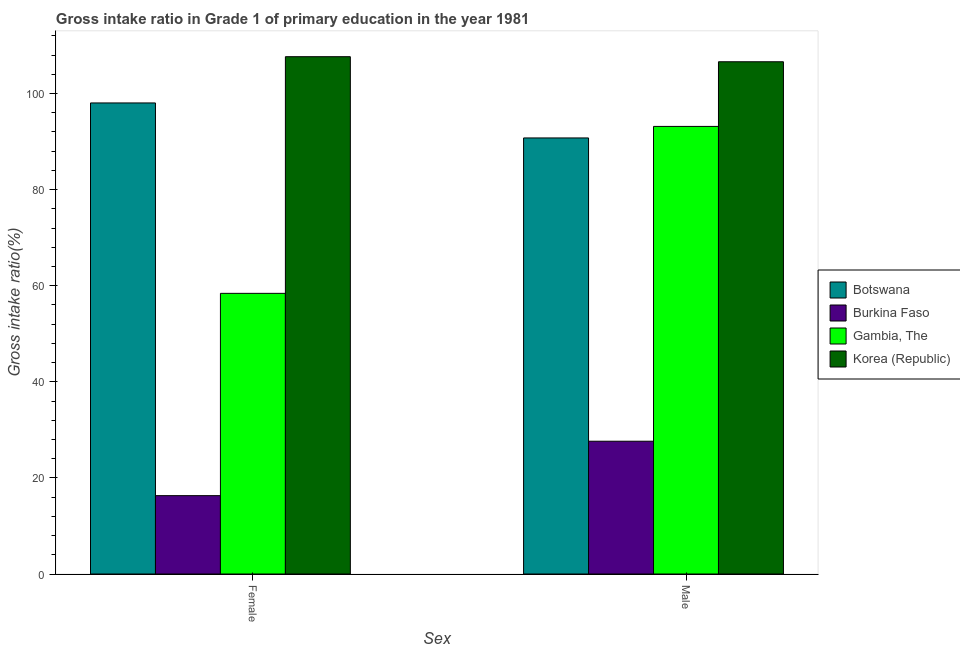How many groups of bars are there?
Make the answer very short. 2. Are the number of bars per tick equal to the number of legend labels?
Provide a succinct answer. Yes. What is the gross intake ratio(female) in Botswana?
Your answer should be very brief. 98.05. Across all countries, what is the maximum gross intake ratio(male)?
Provide a short and direct response. 106.62. Across all countries, what is the minimum gross intake ratio(female)?
Make the answer very short. 16.31. In which country was the gross intake ratio(male) minimum?
Your answer should be very brief. Burkina Faso. What is the total gross intake ratio(male) in the graph?
Keep it short and to the point. 318.18. What is the difference between the gross intake ratio(female) in Korea (Republic) and that in Gambia, The?
Give a very brief answer. 49.26. What is the difference between the gross intake ratio(female) in Burkina Faso and the gross intake ratio(male) in Gambia, The?
Offer a terse response. -76.85. What is the average gross intake ratio(female) per country?
Provide a short and direct response. 70.11. What is the difference between the gross intake ratio(female) and gross intake ratio(male) in Botswana?
Give a very brief answer. 7.28. What is the ratio of the gross intake ratio(female) in Burkina Faso to that in Gambia, The?
Give a very brief answer. 0.28. In how many countries, is the gross intake ratio(female) greater than the average gross intake ratio(female) taken over all countries?
Make the answer very short. 2. What does the 3rd bar from the left in Male represents?
Your answer should be very brief. Gambia, The. What does the 3rd bar from the right in Male represents?
Offer a very short reply. Burkina Faso. How many bars are there?
Keep it short and to the point. 8. How many countries are there in the graph?
Your response must be concise. 4. Are the values on the major ticks of Y-axis written in scientific E-notation?
Give a very brief answer. No. Where does the legend appear in the graph?
Offer a very short reply. Center right. How many legend labels are there?
Offer a very short reply. 4. How are the legend labels stacked?
Offer a terse response. Vertical. What is the title of the graph?
Provide a short and direct response. Gross intake ratio in Grade 1 of primary education in the year 1981. Does "Monaco" appear as one of the legend labels in the graph?
Make the answer very short. No. What is the label or title of the X-axis?
Your answer should be very brief. Sex. What is the label or title of the Y-axis?
Your response must be concise. Gross intake ratio(%). What is the Gross intake ratio(%) in Botswana in Female?
Provide a short and direct response. 98.05. What is the Gross intake ratio(%) of Burkina Faso in Female?
Provide a succinct answer. 16.31. What is the Gross intake ratio(%) of Gambia, The in Female?
Give a very brief answer. 58.41. What is the Gross intake ratio(%) in Korea (Republic) in Female?
Keep it short and to the point. 107.67. What is the Gross intake ratio(%) of Botswana in Male?
Offer a very short reply. 90.76. What is the Gross intake ratio(%) of Burkina Faso in Male?
Keep it short and to the point. 27.64. What is the Gross intake ratio(%) in Gambia, The in Male?
Offer a very short reply. 93.16. What is the Gross intake ratio(%) in Korea (Republic) in Male?
Offer a very short reply. 106.62. Across all Sex, what is the maximum Gross intake ratio(%) in Botswana?
Offer a very short reply. 98.05. Across all Sex, what is the maximum Gross intake ratio(%) of Burkina Faso?
Ensure brevity in your answer.  27.64. Across all Sex, what is the maximum Gross intake ratio(%) of Gambia, The?
Keep it short and to the point. 93.16. Across all Sex, what is the maximum Gross intake ratio(%) in Korea (Republic)?
Offer a terse response. 107.67. Across all Sex, what is the minimum Gross intake ratio(%) in Botswana?
Your response must be concise. 90.76. Across all Sex, what is the minimum Gross intake ratio(%) of Burkina Faso?
Give a very brief answer. 16.31. Across all Sex, what is the minimum Gross intake ratio(%) of Gambia, The?
Give a very brief answer. 58.41. Across all Sex, what is the minimum Gross intake ratio(%) of Korea (Republic)?
Make the answer very short. 106.62. What is the total Gross intake ratio(%) in Botswana in the graph?
Keep it short and to the point. 188.81. What is the total Gross intake ratio(%) in Burkina Faso in the graph?
Your answer should be very brief. 43.95. What is the total Gross intake ratio(%) of Gambia, The in the graph?
Offer a terse response. 151.58. What is the total Gross intake ratio(%) of Korea (Republic) in the graph?
Offer a terse response. 214.29. What is the difference between the Gross intake ratio(%) in Botswana in Female and that in Male?
Ensure brevity in your answer.  7.28. What is the difference between the Gross intake ratio(%) of Burkina Faso in Female and that in Male?
Your answer should be very brief. -11.33. What is the difference between the Gross intake ratio(%) in Gambia, The in Female and that in Male?
Provide a short and direct response. -34.75. What is the difference between the Gross intake ratio(%) in Korea (Republic) in Female and that in Male?
Keep it short and to the point. 1.05. What is the difference between the Gross intake ratio(%) in Botswana in Female and the Gross intake ratio(%) in Burkina Faso in Male?
Your answer should be very brief. 70.41. What is the difference between the Gross intake ratio(%) of Botswana in Female and the Gross intake ratio(%) of Gambia, The in Male?
Your answer should be compact. 4.89. What is the difference between the Gross intake ratio(%) in Botswana in Female and the Gross intake ratio(%) in Korea (Republic) in Male?
Your response must be concise. -8.57. What is the difference between the Gross intake ratio(%) in Burkina Faso in Female and the Gross intake ratio(%) in Gambia, The in Male?
Your answer should be very brief. -76.85. What is the difference between the Gross intake ratio(%) in Burkina Faso in Female and the Gross intake ratio(%) in Korea (Republic) in Male?
Provide a succinct answer. -90.31. What is the difference between the Gross intake ratio(%) of Gambia, The in Female and the Gross intake ratio(%) of Korea (Republic) in Male?
Your answer should be compact. -48.2. What is the average Gross intake ratio(%) in Botswana per Sex?
Give a very brief answer. 94.41. What is the average Gross intake ratio(%) of Burkina Faso per Sex?
Provide a succinct answer. 21.97. What is the average Gross intake ratio(%) in Gambia, The per Sex?
Offer a terse response. 75.79. What is the average Gross intake ratio(%) of Korea (Republic) per Sex?
Your answer should be compact. 107.15. What is the difference between the Gross intake ratio(%) in Botswana and Gross intake ratio(%) in Burkina Faso in Female?
Ensure brevity in your answer.  81.74. What is the difference between the Gross intake ratio(%) in Botswana and Gross intake ratio(%) in Gambia, The in Female?
Keep it short and to the point. 39.63. What is the difference between the Gross intake ratio(%) of Botswana and Gross intake ratio(%) of Korea (Republic) in Female?
Keep it short and to the point. -9.63. What is the difference between the Gross intake ratio(%) of Burkina Faso and Gross intake ratio(%) of Gambia, The in Female?
Provide a succinct answer. -42.11. What is the difference between the Gross intake ratio(%) of Burkina Faso and Gross intake ratio(%) of Korea (Republic) in Female?
Offer a very short reply. -91.37. What is the difference between the Gross intake ratio(%) in Gambia, The and Gross intake ratio(%) in Korea (Republic) in Female?
Your answer should be very brief. -49.26. What is the difference between the Gross intake ratio(%) of Botswana and Gross intake ratio(%) of Burkina Faso in Male?
Offer a very short reply. 63.13. What is the difference between the Gross intake ratio(%) of Botswana and Gross intake ratio(%) of Gambia, The in Male?
Offer a terse response. -2.4. What is the difference between the Gross intake ratio(%) in Botswana and Gross intake ratio(%) in Korea (Republic) in Male?
Give a very brief answer. -15.86. What is the difference between the Gross intake ratio(%) of Burkina Faso and Gross intake ratio(%) of Gambia, The in Male?
Provide a short and direct response. -65.52. What is the difference between the Gross intake ratio(%) in Burkina Faso and Gross intake ratio(%) in Korea (Republic) in Male?
Give a very brief answer. -78.98. What is the difference between the Gross intake ratio(%) in Gambia, The and Gross intake ratio(%) in Korea (Republic) in Male?
Provide a succinct answer. -13.46. What is the ratio of the Gross intake ratio(%) in Botswana in Female to that in Male?
Offer a very short reply. 1.08. What is the ratio of the Gross intake ratio(%) of Burkina Faso in Female to that in Male?
Your response must be concise. 0.59. What is the ratio of the Gross intake ratio(%) in Gambia, The in Female to that in Male?
Your answer should be compact. 0.63. What is the ratio of the Gross intake ratio(%) in Korea (Republic) in Female to that in Male?
Provide a succinct answer. 1.01. What is the difference between the highest and the second highest Gross intake ratio(%) of Botswana?
Provide a succinct answer. 7.28. What is the difference between the highest and the second highest Gross intake ratio(%) of Burkina Faso?
Offer a very short reply. 11.33. What is the difference between the highest and the second highest Gross intake ratio(%) of Gambia, The?
Provide a succinct answer. 34.75. What is the difference between the highest and the second highest Gross intake ratio(%) in Korea (Republic)?
Make the answer very short. 1.05. What is the difference between the highest and the lowest Gross intake ratio(%) in Botswana?
Ensure brevity in your answer.  7.28. What is the difference between the highest and the lowest Gross intake ratio(%) in Burkina Faso?
Offer a terse response. 11.33. What is the difference between the highest and the lowest Gross intake ratio(%) of Gambia, The?
Your answer should be very brief. 34.75. What is the difference between the highest and the lowest Gross intake ratio(%) of Korea (Republic)?
Offer a terse response. 1.05. 